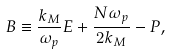<formula> <loc_0><loc_0><loc_500><loc_500>B \equiv \frac { k _ { M } } { \omega _ { p } } E + \frac { N \omega _ { p } } { 2 k _ { M } } - P ,</formula> 